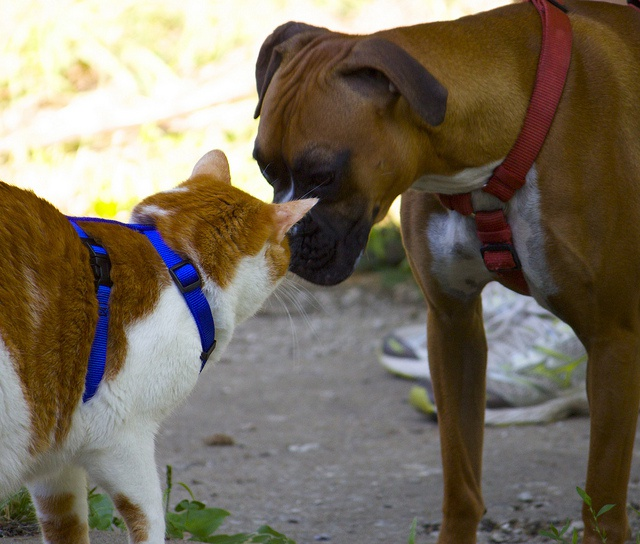Describe the objects in this image and their specific colors. I can see dog in ivory, black, maroon, and gray tones and cat in ivory, maroon, darkgray, olive, and gray tones in this image. 